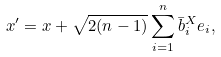<formula> <loc_0><loc_0><loc_500><loc_500>x ^ { \prime } = x + \sqrt { 2 ( n - 1 ) } \sum _ { i = 1 } ^ { n } \bar { b } ^ { X } _ { i } e _ { i } ,</formula> 